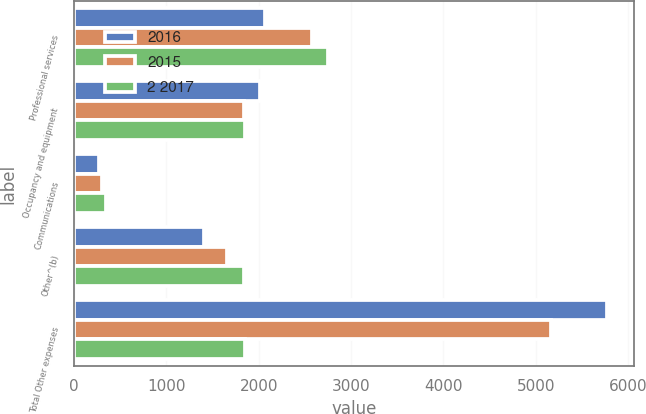Convert chart to OTSL. <chart><loc_0><loc_0><loc_500><loc_500><stacked_bar_chart><ecel><fcel>Professional services<fcel>Occupancy and equipment<fcel>Communications<fcel>Other^(b)<fcel>Total Other expenses<nl><fcel>2016<fcel>2070<fcel>2019<fcel>276<fcel>1411<fcel>5776<nl><fcel>2015<fcel>2583<fcel>1838<fcel>302<fcel>1657<fcel>5162<nl><fcel>2 2017<fcel>2750<fcel>1854<fcel>345<fcel>1844<fcel>1849<nl></chart> 